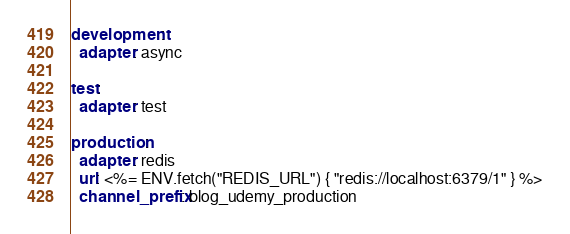<code> <loc_0><loc_0><loc_500><loc_500><_YAML_>development:
  adapter: async

test:
  adapter: test

production:
  adapter: redis
  url: <%= ENV.fetch("REDIS_URL") { "redis://localhost:6379/1" } %>
  channel_prefix: blog_udemy_production
</code> 